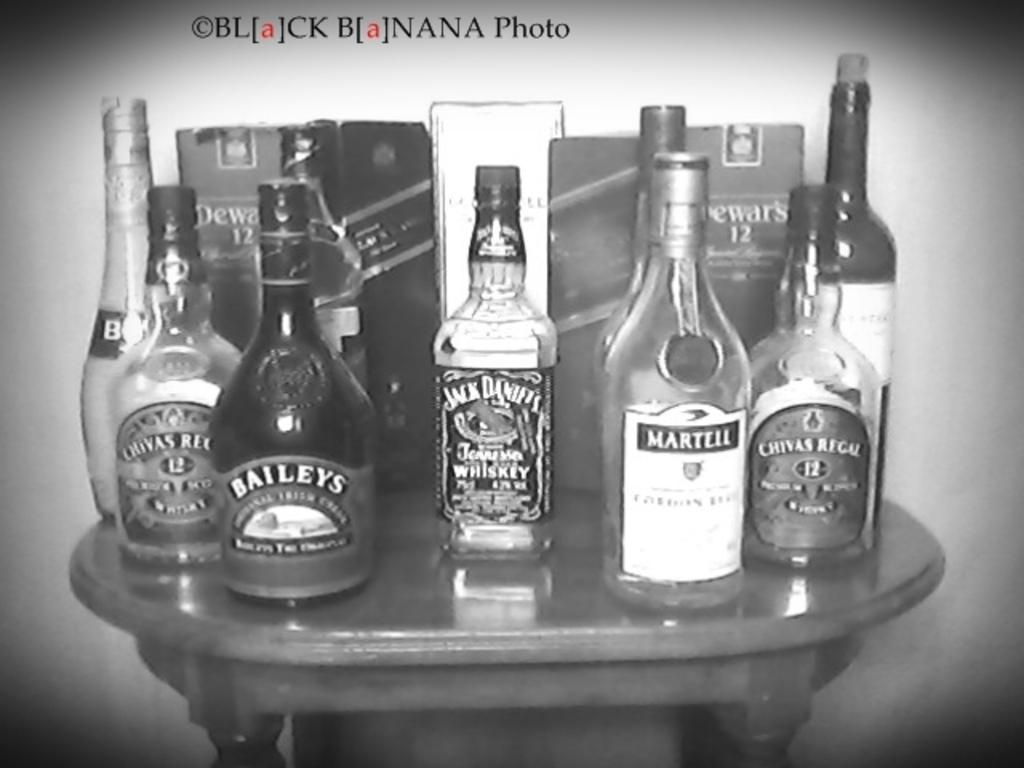<image>
Write a terse but informative summary of the picture. A bunch of bottles of liquor are on a table including Jack Daniel's Whiskey. 